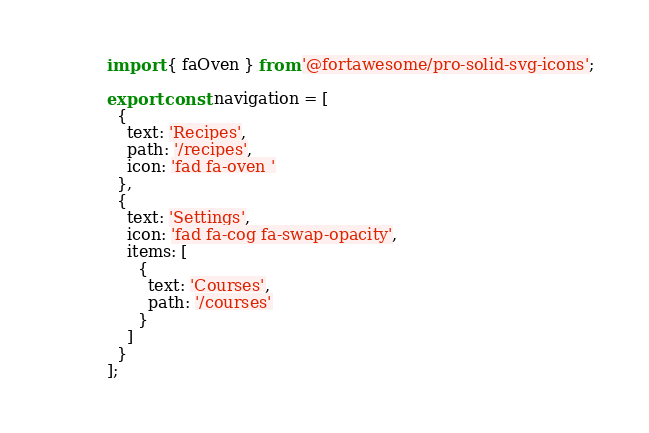<code> <loc_0><loc_0><loc_500><loc_500><_TypeScript_>import { faOven } from '@fortawesome/pro-solid-svg-icons';

export const navigation = [
  {
    text: 'Recipes',
    path: '/recipes',
    icon: 'fad fa-oven '
  },
  {
    text: 'Settings',
    icon: 'fad fa-cog fa-swap-opacity',
    items: [
      {
        text: 'Courses',
        path: '/courses'
      }
    ]
  }
];
</code> 